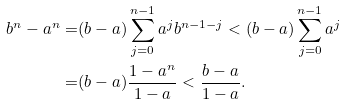<formula> <loc_0><loc_0><loc_500><loc_500>b ^ { n } - a ^ { n } = & ( b - a ) \sum _ { j = 0 } ^ { n - 1 } a ^ { j } b ^ { n - 1 - j } < ( b - a ) \sum _ { j = 0 } ^ { n - 1 } a ^ { j } \\ = & ( b - a ) \frac { 1 - a ^ { n } } { 1 - a } < \frac { b - a } { 1 - a } .</formula> 